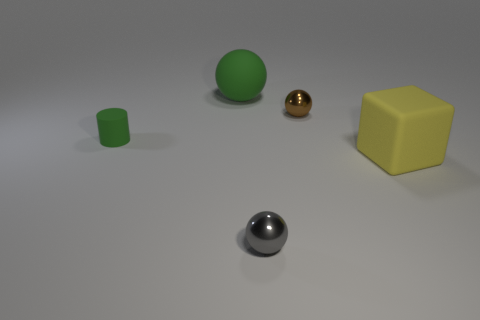Is the number of small spheres in front of the cylinder greater than the number of tiny green things in front of the big matte cube?
Your response must be concise. Yes. How many other things are the same size as the green sphere?
Your answer should be very brief. 1. Is the color of the tiny thing that is left of the tiny gray metallic object the same as the matte sphere?
Keep it short and to the point. Yes. Is the number of big objects that are behind the green rubber cylinder greater than the number of big purple metal cylinders?
Ensure brevity in your answer.  Yes. Are there any other things of the same color as the small rubber cylinder?
Offer a terse response. Yes. There is a green rubber object that is in front of the large thing behind the cylinder; what shape is it?
Keep it short and to the point. Cylinder. Is the number of big yellow matte cubes greater than the number of objects?
Keep it short and to the point. No. What number of things are both to the left of the yellow matte block and to the right of the green rubber ball?
Ensure brevity in your answer.  2. How many metallic things are behind the big rubber thing in front of the brown metal object?
Your answer should be compact. 1. What number of objects are either things to the left of the rubber block or metallic things behind the small matte cylinder?
Provide a succinct answer. 4. 